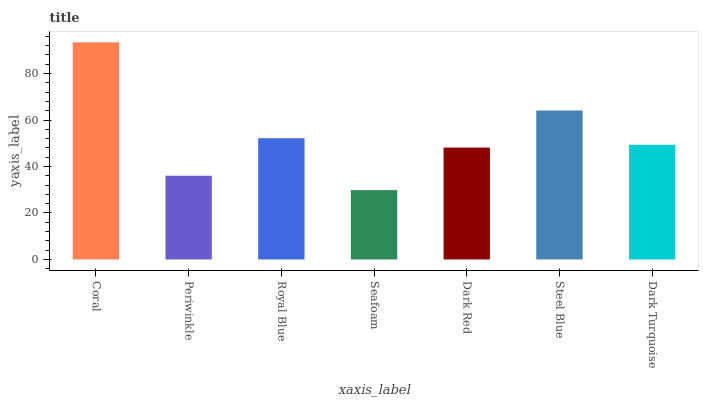Is Seafoam the minimum?
Answer yes or no. Yes. Is Coral the maximum?
Answer yes or no. Yes. Is Periwinkle the minimum?
Answer yes or no. No. Is Periwinkle the maximum?
Answer yes or no. No. Is Coral greater than Periwinkle?
Answer yes or no. Yes. Is Periwinkle less than Coral?
Answer yes or no. Yes. Is Periwinkle greater than Coral?
Answer yes or no. No. Is Coral less than Periwinkle?
Answer yes or no. No. Is Dark Turquoise the high median?
Answer yes or no. Yes. Is Dark Turquoise the low median?
Answer yes or no. Yes. Is Steel Blue the high median?
Answer yes or no. No. Is Coral the low median?
Answer yes or no. No. 